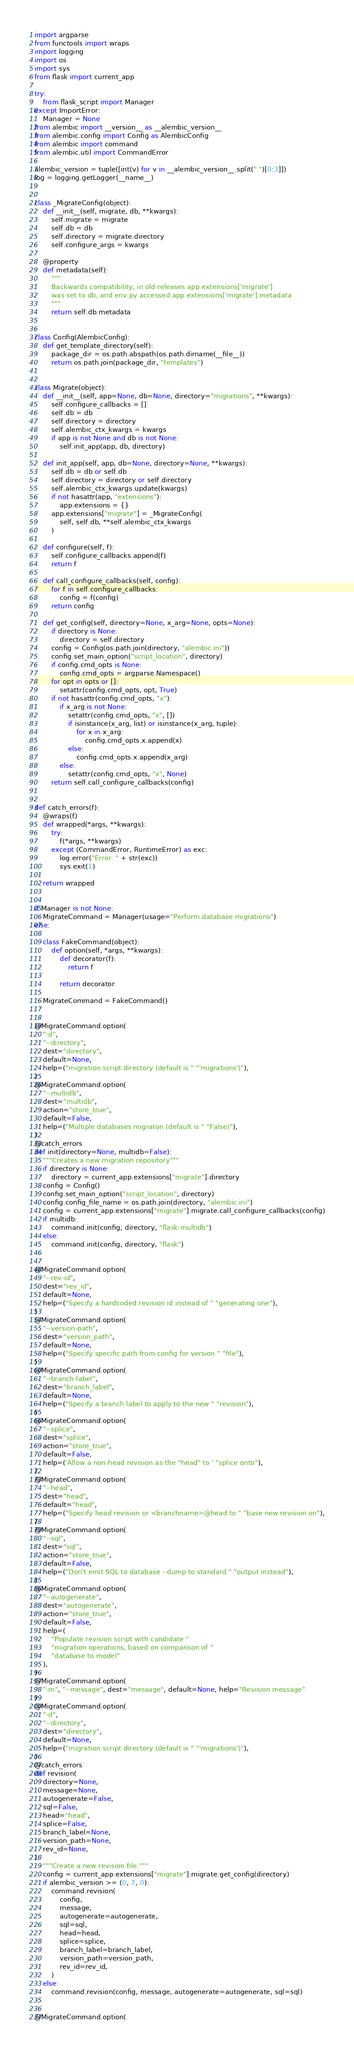Convert code to text. <code><loc_0><loc_0><loc_500><loc_500><_Python_>import argparse
from functools import wraps
import logging
import os
import sys
from flask import current_app

try:
    from flask_script import Manager
except ImportError:
    Manager = None
from alembic import __version__ as __alembic_version__
from alembic.config import Config as AlembicConfig
from alembic import command
from alembic.util import CommandError

alembic_version = tuple([int(v) for v in __alembic_version__.split(".")[0:3]])
log = logging.getLogger(__name__)


class _MigrateConfig(object):
    def __init__(self, migrate, db, **kwargs):
        self.migrate = migrate
        self.db = db
        self.directory = migrate.directory
        self.configure_args = kwargs

    @property
    def metadata(self):
        """
        Backwards compatibility, in old releases app.extensions['migrate']
        was set to db, and env.py accessed app.extensions['migrate'].metadata
        """
        return self.db.metadata


class Config(AlembicConfig):
    def get_template_directory(self):
        package_dir = os.path.abspath(os.path.dirname(__file__))
        return os.path.join(package_dir, "templates")


class Migrate(object):
    def __init__(self, app=None, db=None, directory="migrations", **kwargs):
        self.configure_callbacks = []
        self.db = db
        self.directory = directory
        self.alembic_ctx_kwargs = kwargs
        if app is not None and db is not None:
            self.init_app(app, db, directory)

    def init_app(self, app, db=None, directory=None, **kwargs):
        self.db = db or self.db
        self.directory = directory or self.directory
        self.alembic_ctx_kwargs.update(kwargs)
        if not hasattr(app, "extensions"):
            app.extensions = {}
        app.extensions["migrate"] = _MigrateConfig(
            self, self.db, **self.alembic_ctx_kwargs
        )

    def configure(self, f):
        self.configure_callbacks.append(f)
        return f

    def call_configure_callbacks(self, config):
        for f in self.configure_callbacks:
            config = f(config)
        return config

    def get_config(self, directory=None, x_arg=None, opts=None):
        if directory is None:
            directory = self.directory
        config = Config(os.path.join(directory, "alembic.ini"))
        config.set_main_option("script_location", directory)
        if config.cmd_opts is None:
            config.cmd_opts = argparse.Namespace()
        for opt in opts or []:
            setattr(config.cmd_opts, opt, True)
        if not hasattr(config.cmd_opts, "x"):
            if x_arg is not None:
                setattr(config.cmd_opts, "x", [])
                if isinstance(x_arg, list) or isinstance(x_arg, tuple):
                    for x in x_arg:
                        config.cmd_opts.x.append(x)
                else:
                    config.cmd_opts.x.append(x_arg)
            else:
                setattr(config.cmd_opts, "x", None)
        return self.call_configure_callbacks(config)


def catch_errors(f):
    @wraps(f)
    def wrapped(*args, **kwargs):
        try:
            f(*args, **kwargs)
        except (CommandError, RuntimeError) as exc:
            log.error("Error: " + str(exc))
            sys.exit(1)

    return wrapped


if Manager is not None:
    MigrateCommand = Manager(usage="Perform database migrations")
else:

    class FakeCommand(object):
        def option(self, *args, **kwargs):
            def decorator(f):
                return f

            return decorator

    MigrateCommand = FakeCommand()


@MigrateCommand.option(
    "-d",
    "--directory",
    dest="directory",
    default=None,
    help=("migration script directory (default is " "'migrations')"),
)
@MigrateCommand.option(
    "--multidb",
    dest="multidb",
    action="store_true",
    default=False,
    help=("Multiple databases migraton (default is " "False)"),
)
@catch_errors
def init(directory=None, multidb=False):
    """Creates a new migration repository"""
    if directory is None:
        directory = current_app.extensions["migrate"].directory
    config = Config()
    config.set_main_option("script_location", directory)
    config.config_file_name = os.path.join(directory, "alembic.ini")
    config = current_app.extensions["migrate"].migrate.call_configure_callbacks(config)
    if multidb:
        command.init(config, directory, "flask-multidb")
    else:
        command.init(config, directory, "flask")


@MigrateCommand.option(
    "--rev-id",
    dest="rev_id",
    default=None,
    help=("Specify a hardcoded revision id instead of " "generating one"),
)
@MigrateCommand.option(
    "--version-path",
    dest="version_path",
    default=None,
    help=("Specify specific path from config for version " "file"),
)
@MigrateCommand.option(
    "--branch-label",
    dest="branch_label",
    default=None,
    help=("Specify a branch label to apply to the new " "revision"),
)
@MigrateCommand.option(
    "--splice",
    dest="splice",
    action="store_true",
    default=False,
    help=('Allow a non-head revision as the "head" to ' "splice onto"),
)
@MigrateCommand.option(
    "--head",
    dest="head",
    default="head",
    help=("Specify head revision or <branchname>@head to " "base new revision on"),
)
@MigrateCommand.option(
    "--sql",
    dest="sql",
    action="store_true",
    default=False,
    help=("Don't emit SQL to database - dump to standard " "output instead"),
)
@MigrateCommand.option(
    "--autogenerate",
    dest="autogenerate",
    action="store_true",
    default=False,
    help=(
        "Populate revision script with candidate "
        "migration operations, based on comparison of "
        "database to model"
    ),
)
@MigrateCommand.option(
    "-m", "--message", dest="message", default=None, help="Revision message"
)
@MigrateCommand.option(
    "-d",
    "--directory",
    dest="directory",
    default=None,
    help=("migration script directory (default is " "'migrations')"),
)
@catch_errors
def revision(
    directory=None,
    message=None,
    autogenerate=False,
    sql=False,
    head="head",
    splice=False,
    branch_label=None,
    version_path=None,
    rev_id=None,
):
    """Create a new revision file."""
    config = current_app.extensions["migrate"].migrate.get_config(directory)
    if alembic_version >= (0, 7, 0):
        command.revision(
            config,
            message,
            autogenerate=autogenerate,
            sql=sql,
            head=head,
            splice=splice,
            branch_label=branch_label,
            version_path=version_path,
            rev_id=rev_id,
        )
    else:
        command.revision(config, message, autogenerate=autogenerate, sql=sql)


@MigrateCommand.option(</code> 